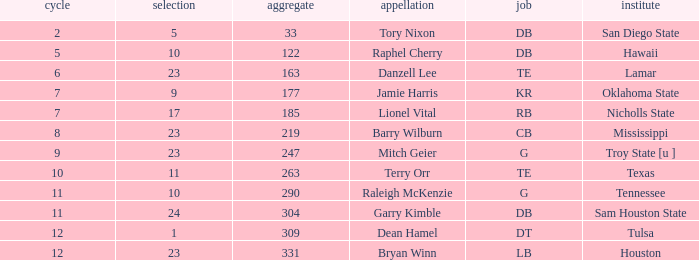How many Picks have an Overall smaller than 304, and a Position of g, and a Round smaller than 11? 1.0. 